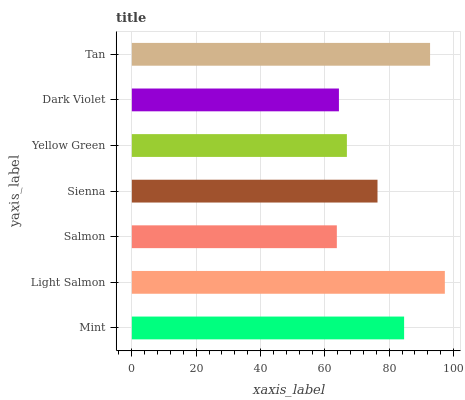Is Salmon the minimum?
Answer yes or no. Yes. Is Light Salmon the maximum?
Answer yes or no. Yes. Is Light Salmon the minimum?
Answer yes or no. No. Is Salmon the maximum?
Answer yes or no. No. Is Light Salmon greater than Salmon?
Answer yes or no. Yes. Is Salmon less than Light Salmon?
Answer yes or no. Yes. Is Salmon greater than Light Salmon?
Answer yes or no. No. Is Light Salmon less than Salmon?
Answer yes or no. No. Is Sienna the high median?
Answer yes or no. Yes. Is Sienna the low median?
Answer yes or no. Yes. Is Dark Violet the high median?
Answer yes or no. No. Is Dark Violet the low median?
Answer yes or no. No. 